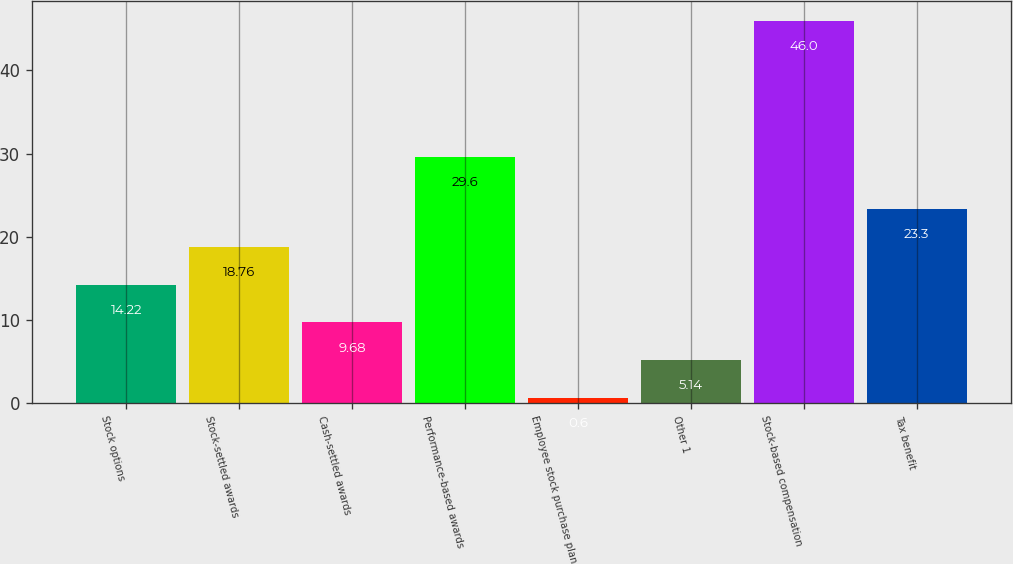<chart> <loc_0><loc_0><loc_500><loc_500><bar_chart><fcel>Stock options<fcel>Stock-settled awards<fcel>Cash-settled awards<fcel>Performance-based awards<fcel>Employee stock purchase plan<fcel>Other 1<fcel>Stock-based compensation<fcel>Tax benefit<nl><fcel>14.22<fcel>18.76<fcel>9.68<fcel>29.6<fcel>0.6<fcel>5.14<fcel>46<fcel>23.3<nl></chart> 